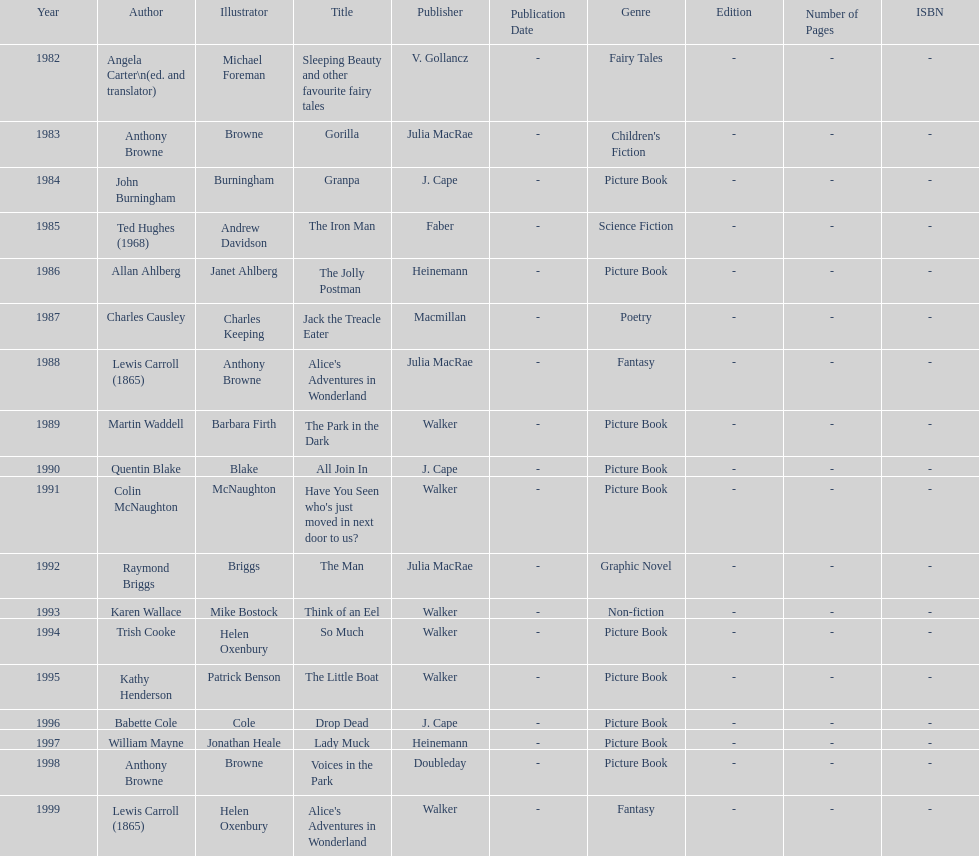How many times has anthony browne won an kurt maschler award for illustration? 3. 